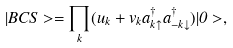<formula> <loc_0><loc_0><loc_500><loc_500>| B C S > = \prod _ { k } ( u _ { k } + v _ { k } a ^ { \dagger } _ { k \uparrow } a ^ { \dagger } _ { - k \downarrow } ) | 0 > ,</formula> 